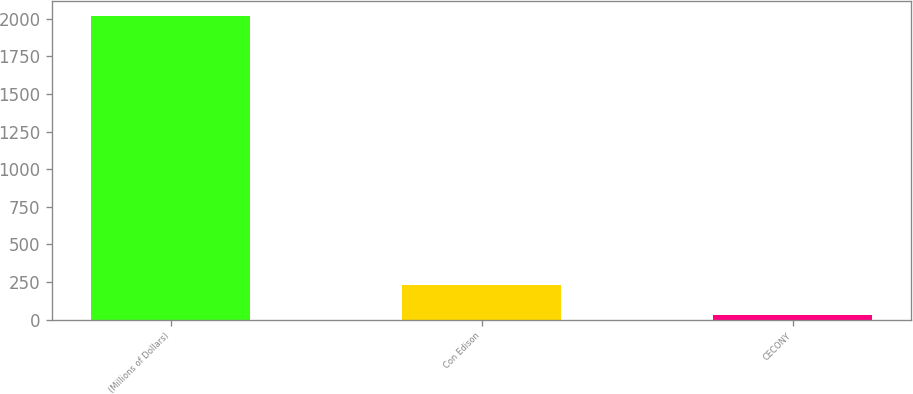Convert chart to OTSL. <chart><loc_0><loc_0><loc_500><loc_500><bar_chart><fcel>(Millions of Dollars)<fcel>Con Edison<fcel>CECONY<nl><fcel>2015<fcel>227.6<fcel>29<nl></chart> 